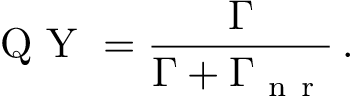Convert formula to latex. <formula><loc_0><loc_0><loc_500><loc_500>Q Y = \frac { \Gamma } { \Gamma + \Gamma _ { n r } } \, .</formula> 